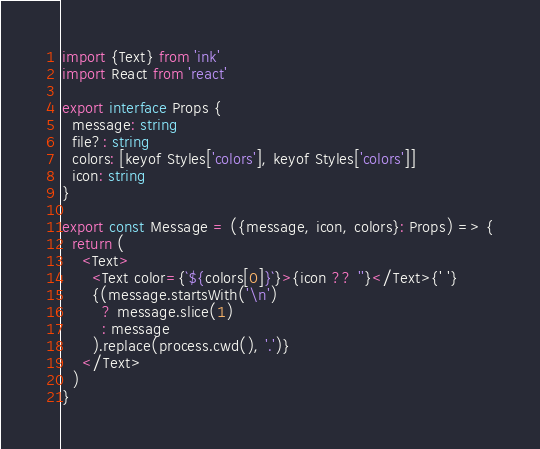Convert code to text. <code><loc_0><loc_0><loc_500><loc_500><_TypeScript_>import {Text} from 'ink'
import React from 'react'

export interface Props {
  message: string
  file?: string
  colors: [keyof Styles['colors'], keyof Styles['colors']]
  icon: string
}

export const Message = ({message, icon, colors}: Props) => {
  return (
    <Text>
      <Text color={`${colors[0]}`}>{icon ?? ''}</Text>{' '}
      {(message.startsWith('\n')
        ? message.slice(1)
        : message
      ).replace(process.cwd(), '.')}
    </Text>
  )
}
</code> 